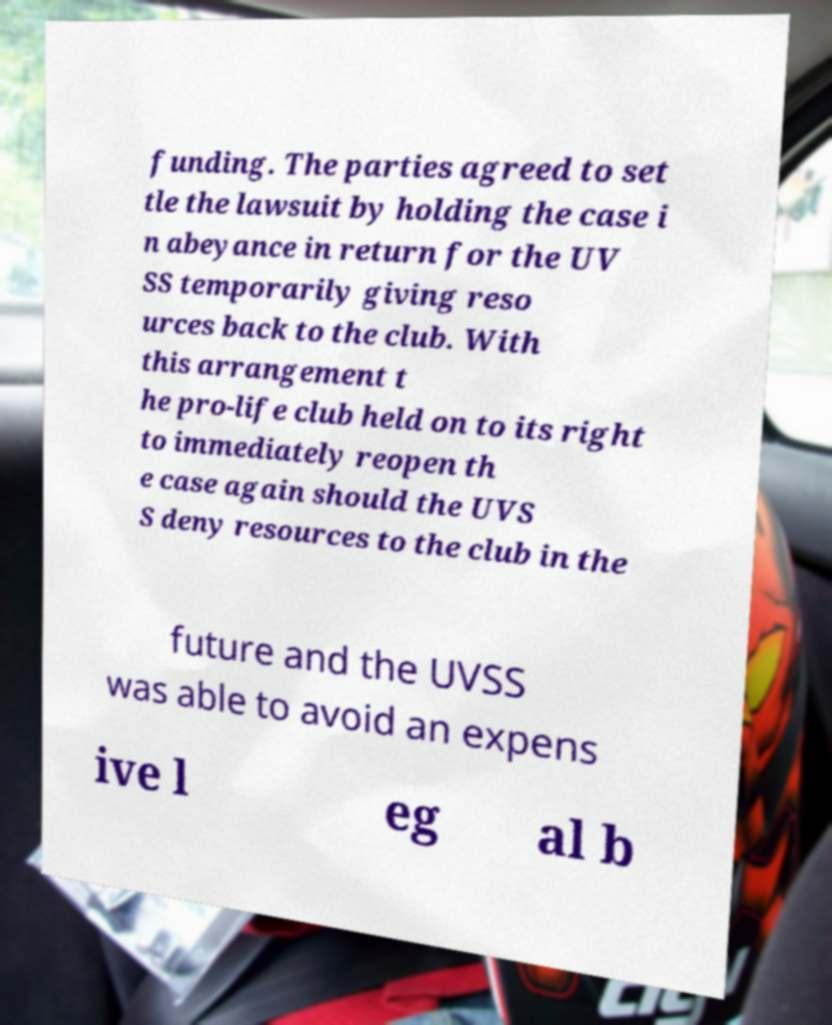Can you read and provide the text displayed in the image?This photo seems to have some interesting text. Can you extract and type it out for me? funding. The parties agreed to set tle the lawsuit by holding the case i n abeyance in return for the UV SS temporarily giving reso urces back to the club. With this arrangement t he pro-life club held on to its right to immediately reopen th e case again should the UVS S deny resources to the club in the future and the UVSS was able to avoid an expens ive l eg al b 